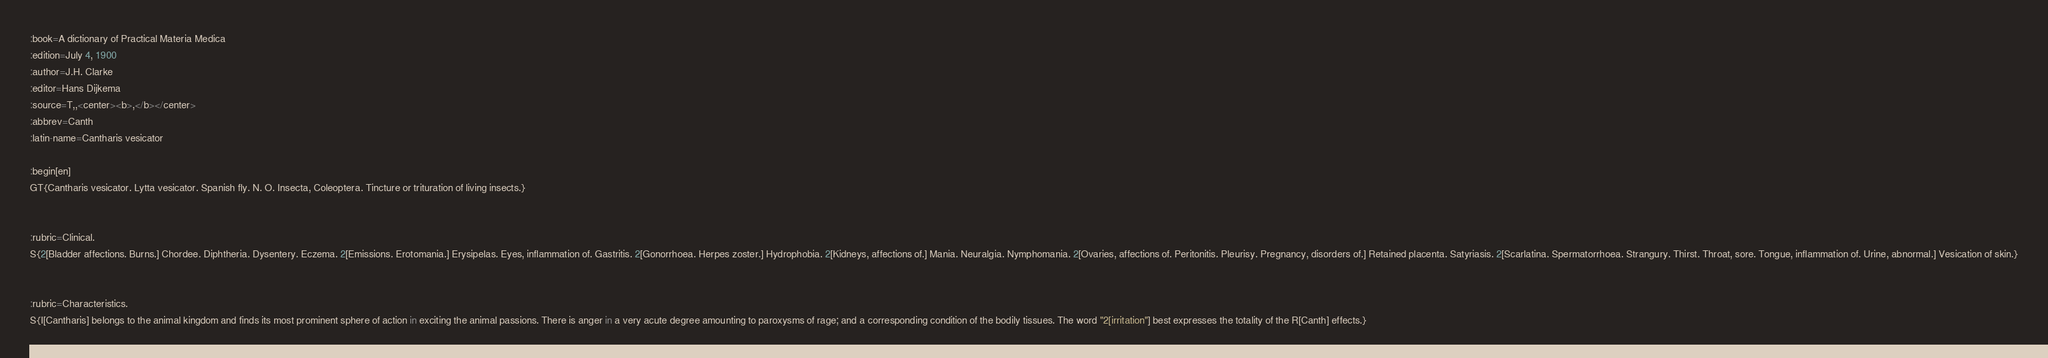Convert code to text. <code><loc_0><loc_0><loc_500><loc_500><_ObjectiveC_>:book=A dictionary of Practical Materia Medica
:edition=July 4, 1900
:author=J.H. Clarke
:editor=Hans Dijkema
:source=T,,<center><b>,</b></center>
:abbrev=Canth
:latin-name=Cantharis vesicator

:begin[en]
GT{Cantharis vesicator. Lytta vesicator. Spanish fly. N. O. Insecta, Coleoptera. Tincture or trituration of living insects.}


:rubric=Clinical.
S{2[Bladder affections. Burns.] Chordee. Diphtheria. Dysentery. Eczema. 2[Emissions. Erotomania.] Erysipelas. Eyes, inflammation of. Gastritis. 2[Gonorrhoea. Herpes zoster.] Hydrophobia. 2[Kidneys, affections of.] Mania. Neuralgia. Nymphomania. 2[Ovaries, affections of. Peritonitis. Pleurisy. Pregnancy, disorders of.] Retained placenta. Satyriasis. 2[Scarlatina. Spermatorrhoea. Strangury. Thirst. Throat, sore. Tongue, inflammation of. Urine, abnormal.] Vesication of skin.}


:rubric=Characteristics.
S{I[Cantharis] belongs to the animal kingdom and finds its most prominent sphere of action in exciting the animal passions. There is anger in a very acute degree amounting to paroxysms of rage; and a corresponding condition of the bodily tissues. The word "2[irritation"] best expresses the totality of the R[Canth] effects.} 
</code> 